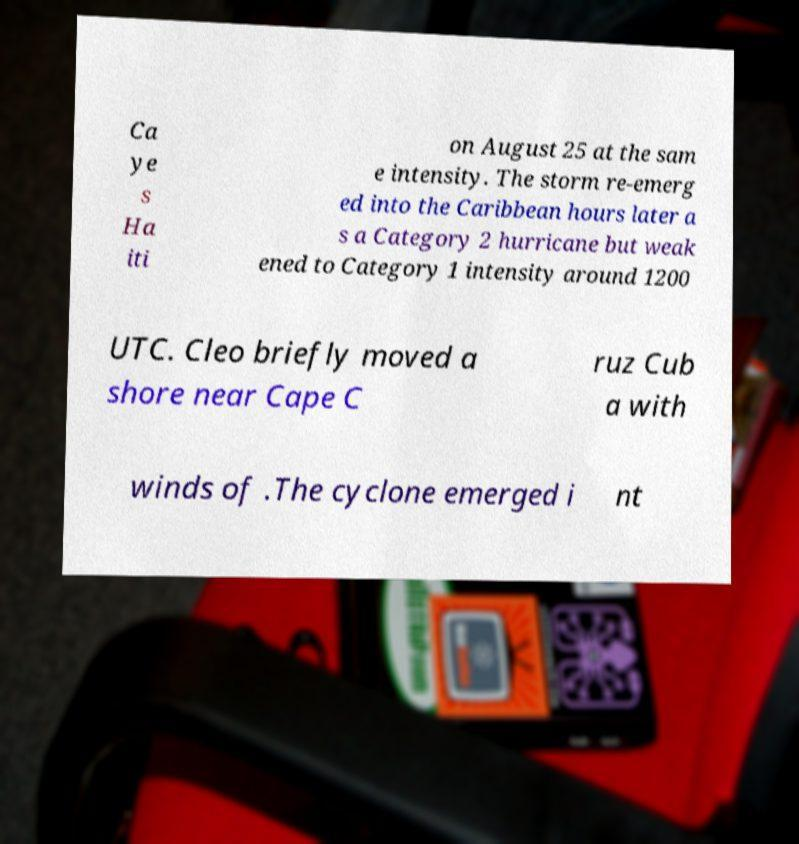Please identify and transcribe the text found in this image. Ca ye s Ha iti on August 25 at the sam e intensity. The storm re-emerg ed into the Caribbean hours later a s a Category 2 hurricane but weak ened to Category 1 intensity around 1200 UTC. Cleo briefly moved a shore near Cape C ruz Cub a with winds of .The cyclone emerged i nt 